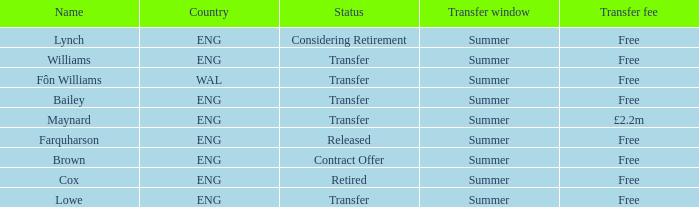What do you call the free transfer fee that has a transfer status and is associated with an eng country? Bailey, Williams, Lowe. 